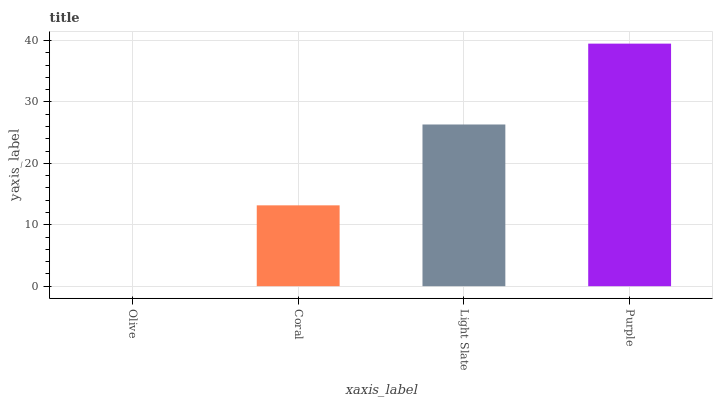Is Olive the minimum?
Answer yes or no. Yes. Is Purple the maximum?
Answer yes or no. Yes. Is Coral the minimum?
Answer yes or no. No. Is Coral the maximum?
Answer yes or no. No. Is Coral greater than Olive?
Answer yes or no. Yes. Is Olive less than Coral?
Answer yes or no. Yes. Is Olive greater than Coral?
Answer yes or no. No. Is Coral less than Olive?
Answer yes or no. No. Is Light Slate the high median?
Answer yes or no. Yes. Is Coral the low median?
Answer yes or no. Yes. Is Purple the high median?
Answer yes or no. No. Is Olive the low median?
Answer yes or no. No. 